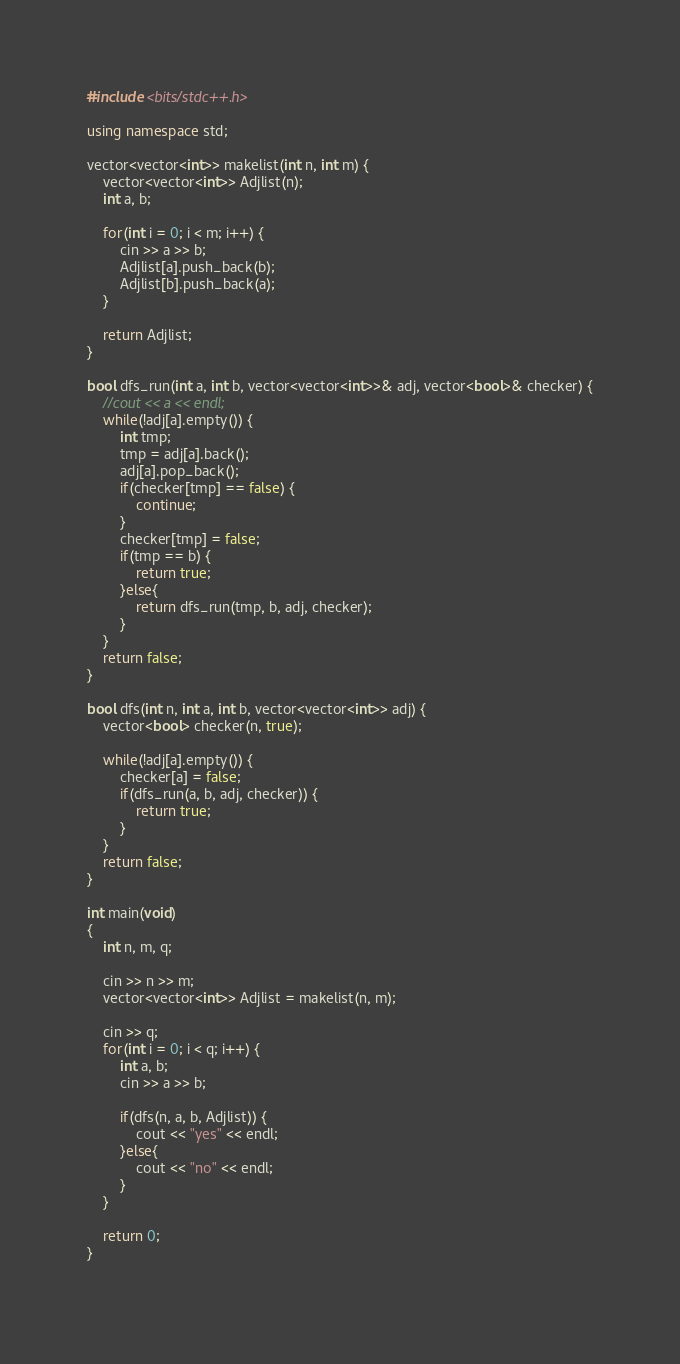<code> <loc_0><loc_0><loc_500><loc_500><_C++_>#include <bits/stdc++.h>

using namespace std;

vector<vector<int>> makelist(int n, int m) {
	vector<vector<int>> Adjlist(n);
	int a, b;

	for(int i = 0; i < m; i++) {
		cin >> a >> b;
		Adjlist[a].push_back(b);
		Adjlist[b].push_back(a);
	}

	return Adjlist;
}

bool dfs_run(int a, int b, vector<vector<int>>& adj, vector<bool>& checker) {
	//cout << a << endl;
	while(!adj[a].empty()) {
		int tmp;
		tmp = adj[a].back();
		adj[a].pop_back();	
		if(checker[tmp] == false) {
			continue;
		}
		checker[tmp] = false;
		if(tmp == b) {
			return true;
		}else{
			return dfs_run(tmp, b, adj, checker);
		}
	}
	return false;
}

bool dfs(int n, int a, int b, vector<vector<int>> adj) {
	vector<bool> checker(n, true);
	
	while(!adj[a].empty()) {
		checker[a] = false;
		if(dfs_run(a, b, adj, checker)) {
			return true;
		}
	}
	return false;
}

int main(void)
{
	int n, m, q;

	cin >> n >> m;
	vector<vector<int>> Adjlist = makelist(n, m);

	cin >> q;
	for(int i = 0; i < q; i++) {
		int a, b;
		cin >> a >> b;

		if(dfs(n, a, b, Adjlist)) {
			cout << "yes" << endl;
		}else{
			cout << "no" << endl;
		}
	}

	return 0;
}
		</code> 